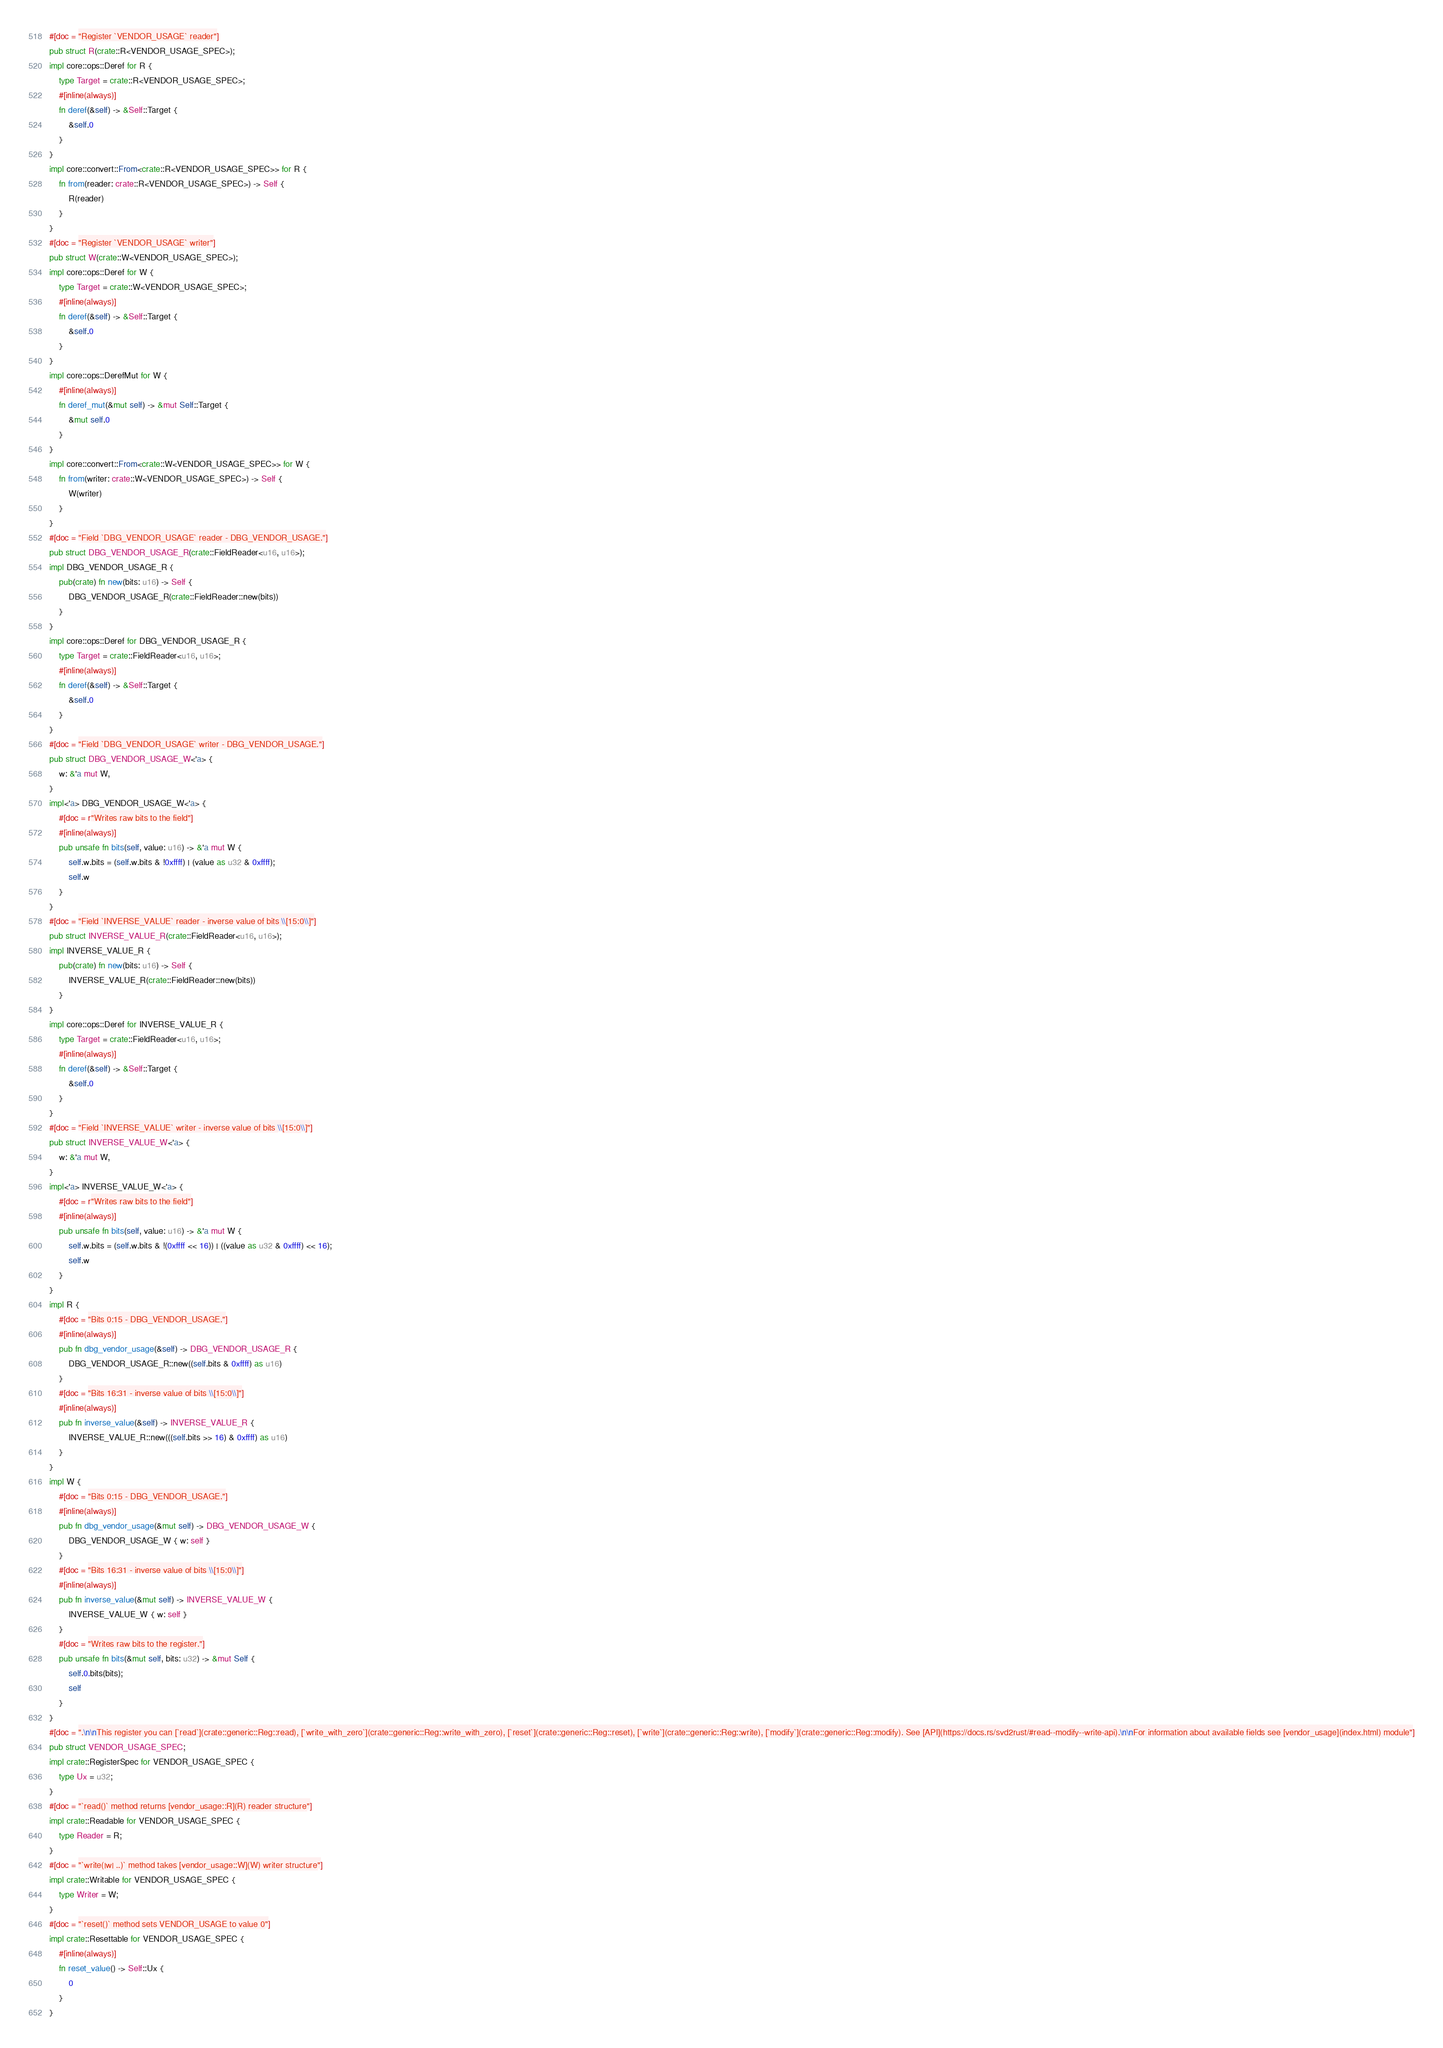Convert code to text. <code><loc_0><loc_0><loc_500><loc_500><_Rust_>#[doc = "Register `VENDOR_USAGE` reader"]
pub struct R(crate::R<VENDOR_USAGE_SPEC>);
impl core::ops::Deref for R {
    type Target = crate::R<VENDOR_USAGE_SPEC>;
    #[inline(always)]
    fn deref(&self) -> &Self::Target {
        &self.0
    }
}
impl core::convert::From<crate::R<VENDOR_USAGE_SPEC>> for R {
    fn from(reader: crate::R<VENDOR_USAGE_SPEC>) -> Self {
        R(reader)
    }
}
#[doc = "Register `VENDOR_USAGE` writer"]
pub struct W(crate::W<VENDOR_USAGE_SPEC>);
impl core::ops::Deref for W {
    type Target = crate::W<VENDOR_USAGE_SPEC>;
    #[inline(always)]
    fn deref(&self) -> &Self::Target {
        &self.0
    }
}
impl core::ops::DerefMut for W {
    #[inline(always)]
    fn deref_mut(&mut self) -> &mut Self::Target {
        &mut self.0
    }
}
impl core::convert::From<crate::W<VENDOR_USAGE_SPEC>> for W {
    fn from(writer: crate::W<VENDOR_USAGE_SPEC>) -> Self {
        W(writer)
    }
}
#[doc = "Field `DBG_VENDOR_USAGE` reader - DBG_VENDOR_USAGE."]
pub struct DBG_VENDOR_USAGE_R(crate::FieldReader<u16, u16>);
impl DBG_VENDOR_USAGE_R {
    pub(crate) fn new(bits: u16) -> Self {
        DBG_VENDOR_USAGE_R(crate::FieldReader::new(bits))
    }
}
impl core::ops::Deref for DBG_VENDOR_USAGE_R {
    type Target = crate::FieldReader<u16, u16>;
    #[inline(always)]
    fn deref(&self) -> &Self::Target {
        &self.0
    }
}
#[doc = "Field `DBG_VENDOR_USAGE` writer - DBG_VENDOR_USAGE."]
pub struct DBG_VENDOR_USAGE_W<'a> {
    w: &'a mut W,
}
impl<'a> DBG_VENDOR_USAGE_W<'a> {
    #[doc = r"Writes raw bits to the field"]
    #[inline(always)]
    pub unsafe fn bits(self, value: u16) -> &'a mut W {
        self.w.bits = (self.w.bits & !0xffff) | (value as u32 & 0xffff);
        self.w
    }
}
#[doc = "Field `INVERSE_VALUE` reader - inverse value of bits \\[15:0\\]"]
pub struct INVERSE_VALUE_R(crate::FieldReader<u16, u16>);
impl INVERSE_VALUE_R {
    pub(crate) fn new(bits: u16) -> Self {
        INVERSE_VALUE_R(crate::FieldReader::new(bits))
    }
}
impl core::ops::Deref for INVERSE_VALUE_R {
    type Target = crate::FieldReader<u16, u16>;
    #[inline(always)]
    fn deref(&self) -> &Self::Target {
        &self.0
    }
}
#[doc = "Field `INVERSE_VALUE` writer - inverse value of bits \\[15:0\\]"]
pub struct INVERSE_VALUE_W<'a> {
    w: &'a mut W,
}
impl<'a> INVERSE_VALUE_W<'a> {
    #[doc = r"Writes raw bits to the field"]
    #[inline(always)]
    pub unsafe fn bits(self, value: u16) -> &'a mut W {
        self.w.bits = (self.w.bits & !(0xffff << 16)) | ((value as u32 & 0xffff) << 16);
        self.w
    }
}
impl R {
    #[doc = "Bits 0:15 - DBG_VENDOR_USAGE."]
    #[inline(always)]
    pub fn dbg_vendor_usage(&self) -> DBG_VENDOR_USAGE_R {
        DBG_VENDOR_USAGE_R::new((self.bits & 0xffff) as u16)
    }
    #[doc = "Bits 16:31 - inverse value of bits \\[15:0\\]"]
    #[inline(always)]
    pub fn inverse_value(&self) -> INVERSE_VALUE_R {
        INVERSE_VALUE_R::new(((self.bits >> 16) & 0xffff) as u16)
    }
}
impl W {
    #[doc = "Bits 0:15 - DBG_VENDOR_USAGE."]
    #[inline(always)]
    pub fn dbg_vendor_usage(&mut self) -> DBG_VENDOR_USAGE_W {
        DBG_VENDOR_USAGE_W { w: self }
    }
    #[doc = "Bits 16:31 - inverse value of bits \\[15:0\\]"]
    #[inline(always)]
    pub fn inverse_value(&mut self) -> INVERSE_VALUE_W {
        INVERSE_VALUE_W { w: self }
    }
    #[doc = "Writes raw bits to the register."]
    pub unsafe fn bits(&mut self, bits: u32) -> &mut Self {
        self.0.bits(bits);
        self
    }
}
#[doc = ".\n\nThis register you can [`read`](crate::generic::Reg::read), [`write_with_zero`](crate::generic::Reg::write_with_zero), [`reset`](crate::generic::Reg::reset), [`write`](crate::generic::Reg::write), [`modify`](crate::generic::Reg::modify). See [API](https://docs.rs/svd2rust/#read--modify--write-api).\n\nFor information about available fields see [vendor_usage](index.html) module"]
pub struct VENDOR_USAGE_SPEC;
impl crate::RegisterSpec for VENDOR_USAGE_SPEC {
    type Ux = u32;
}
#[doc = "`read()` method returns [vendor_usage::R](R) reader structure"]
impl crate::Readable for VENDOR_USAGE_SPEC {
    type Reader = R;
}
#[doc = "`write(|w| ..)` method takes [vendor_usage::W](W) writer structure"]
impl crate::Writable for VENDOR_USAGE_SPEC {
    type Writer = W;
}
#[doc = "`reset()` method sets VENDOR_USAGE to value 0"]
impl crate::Resettable for VENDOR_USAGE_SPEC {
    #[inline(always)]
    fn reset_value() -> Self::Ux {
        0
    }
}
</code> 